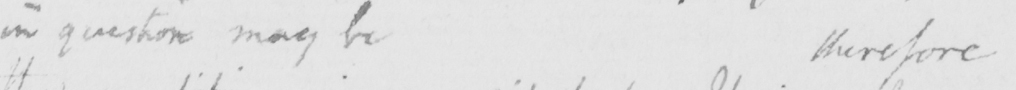Can you tell me what this handwritten text says? in question may betherefore 